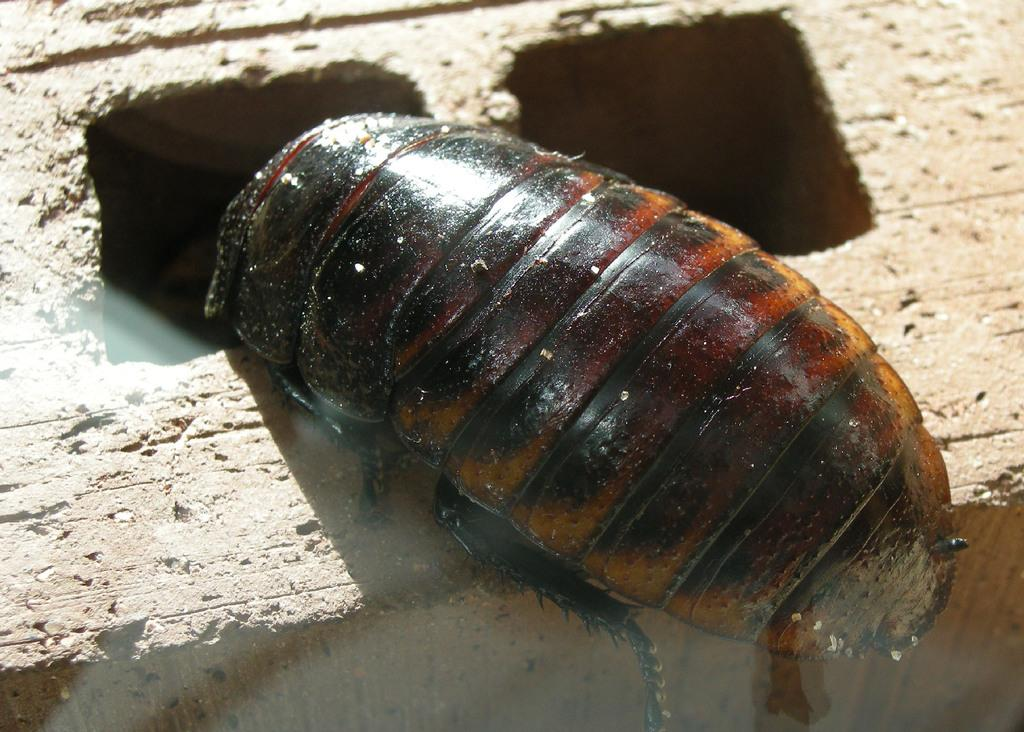What type of creature can be seen in the picture? There is an insect in the picture. What is the insect sitting on? The insect is on a stone surface. Can you describe any other features in the image? There are holes visible in the image. What type of lunch is the insect eating in the image? There is no lunch present in the image, as it features an insect on a stone surface with holes. 